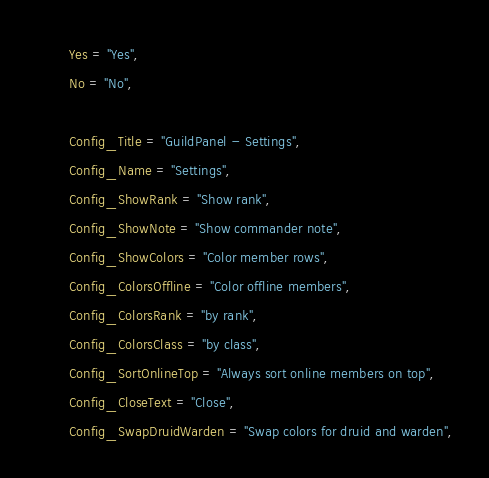Convert code to text. <code><loc_0><loc_0><loc_500><loc_500><_Lua_>        Yes = "Yes",
        No = "No",

        Config_Title = "GuildPanel - Settings",
        Config_Name = "Settings",        
        Config_ShowRank = "Show rank",
        Config_ShowNote = "Show commander note",
        Config_ShowColors = "Color member rows",
        Config_ColorsOffline = "Color offline members",
        Config_ColorsRank = "by rank",
        Config_ColorsClass = "by class",
        Config_SortOnlineTop = "Always sort online members on top",
        Config_CloseText = "Close",
        Config_SwapDruidWarden = "Swap colors for druid and warden",</code> 